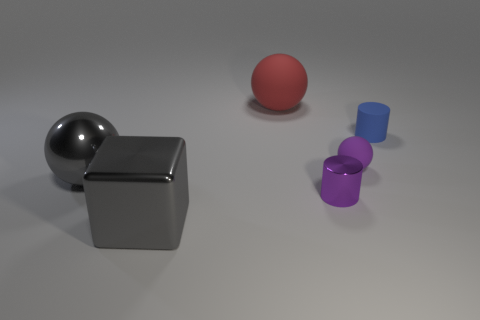Add 4 cylinders. How many objects exist? 10 Subtract all cubes. How many objects are left? 5 Subtract all small purple rubber spheres. Subtract all small rubber spheres. How many objects are left? 4 Add 3 large gray balls. How many large gray balls are left? 4 Add 6 tiny metallic cylinders. How many tiny metallic cylinders exist? 7 Subtract 0 cyan spheres. How many objects are left? 6 